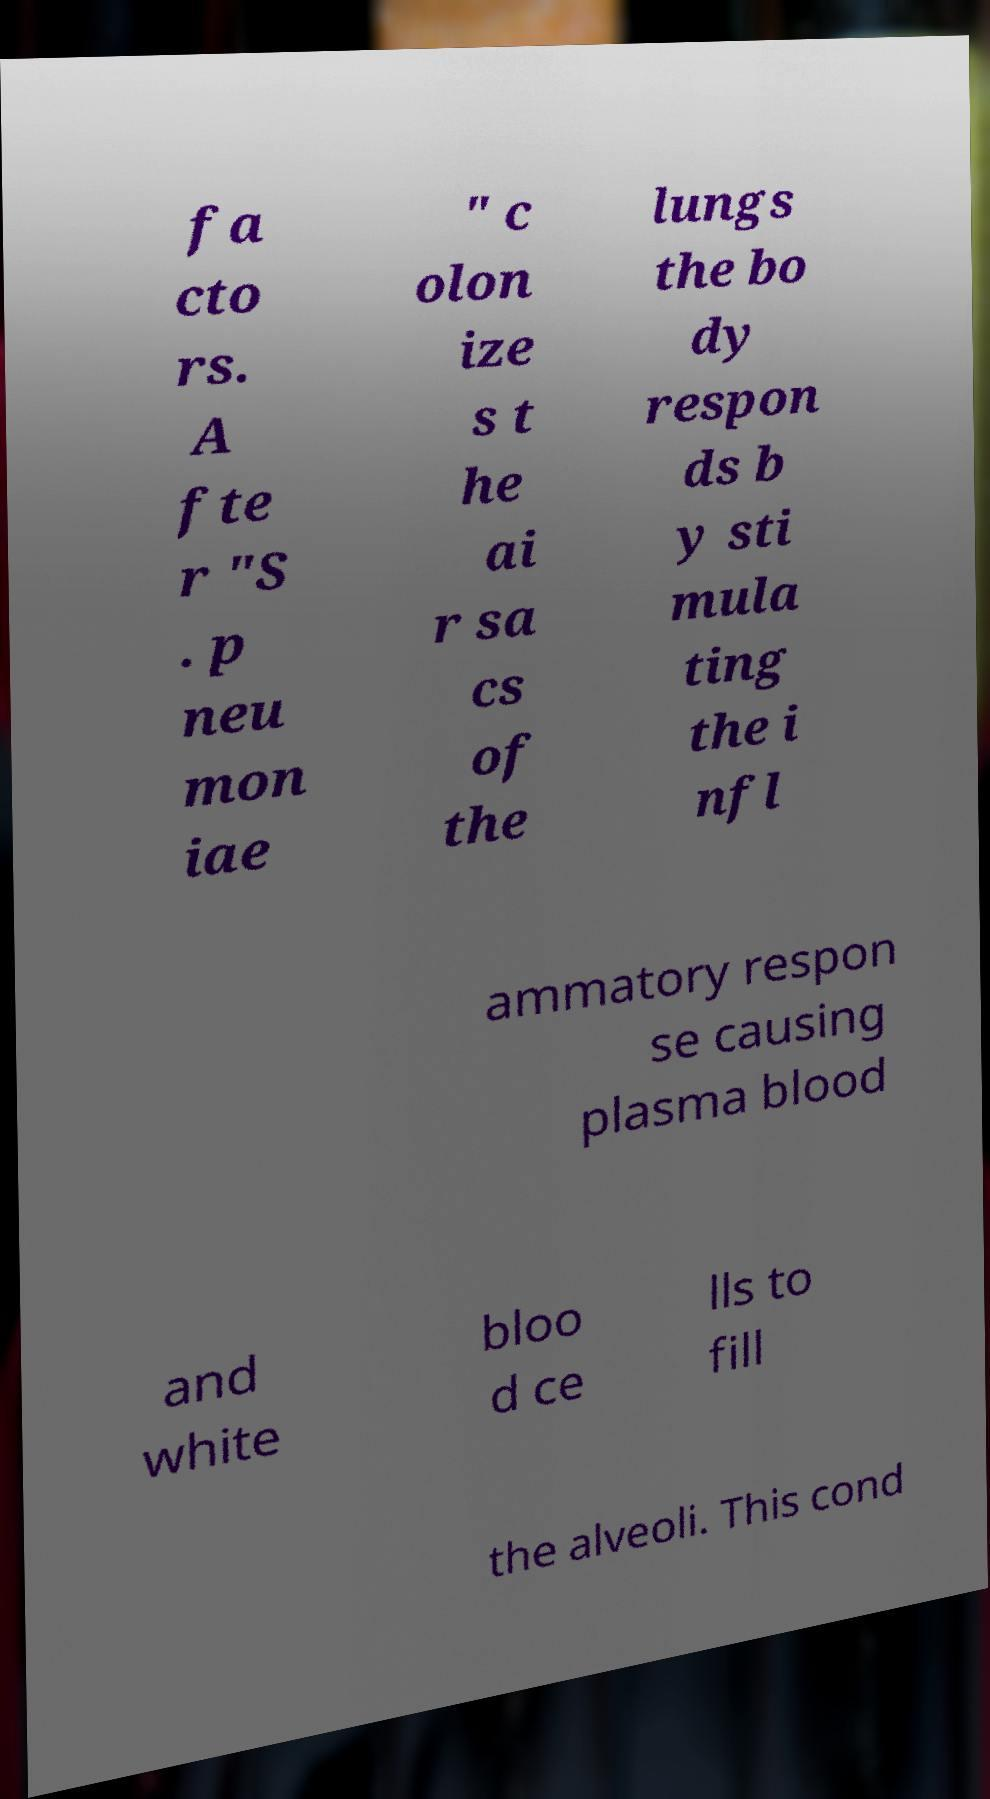Please identify and transcribe the text found in this image. fa cto rs. A fte r "S . p neu mon iae " c olon ize s t he ai r sa cs of the lungs the bo dy respon ds b y sti mula ting the i nfl ammatory respon se causing plasma blood and white bloo d ce lls to fill the alveoli. This cond 